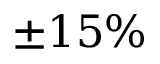<formula> <loc_0><loc_0><loc_500><loc_500>\pm 1 5 \%</formula> 